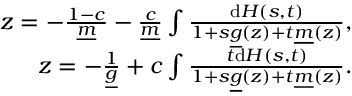Convert formula to latex. <formula><loc_0><loc_0><loc_500><loc_500>\begin{array} { r } { z = - \frac { 1 - c } { \underline { m } } - \frac { c } { \underline { m } } \int \frac { d H ( s , t ) } { 1 + s \underline { g } ( z ) + t \underline { m } ( z ) } , } \\ { z = - \frac { 1 } { \underline { g } } + c \int \frac { t d H ( s , t ) } { 1 + s \underline { g } ( z ) + t \underline { m } ( z ) } . } \end{array}</formula> 